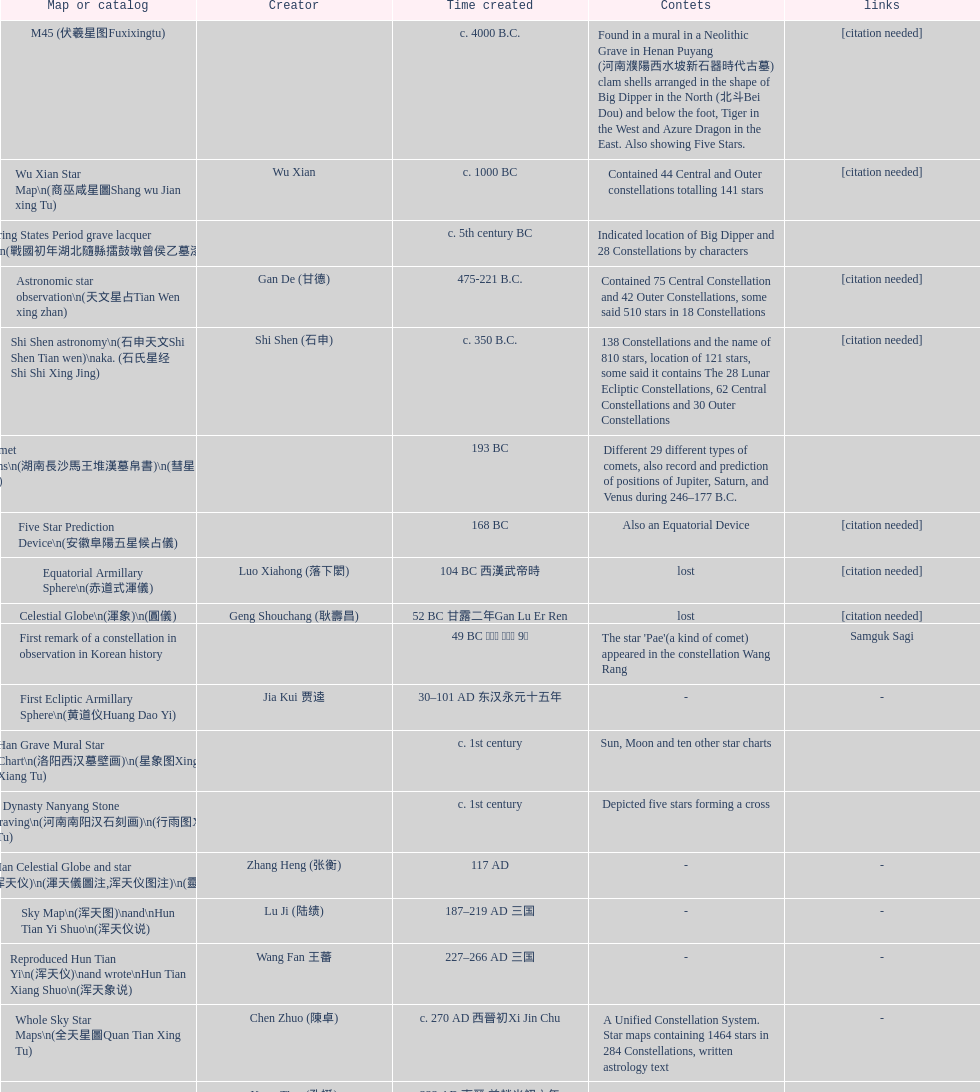What is the variation between the creation date of the five star prediction device and the creation date of the han comet diagrams? 25 years. 